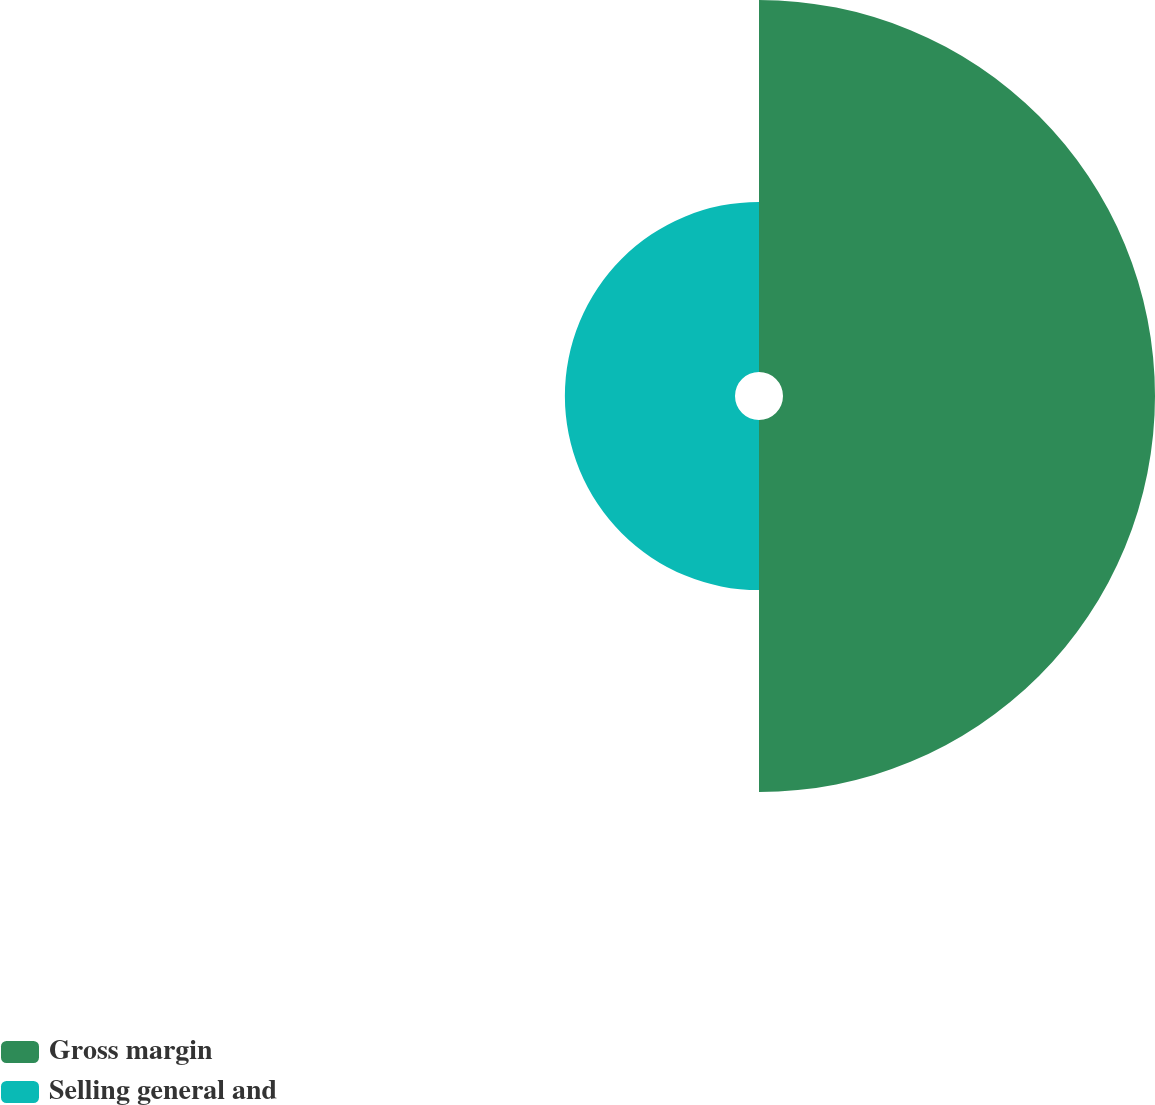<chart> <loc_0><loc_0><loc_500><loc_500><pie_chart><fcel>Gross margin<fcel>Selling general and<nl><fcel>68.62%<fcel>31.38%<nl></chart> 